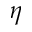Convert formula to latex. <formula><loc_0><loc_0><loc_500><loc_500>\eta</formula> 